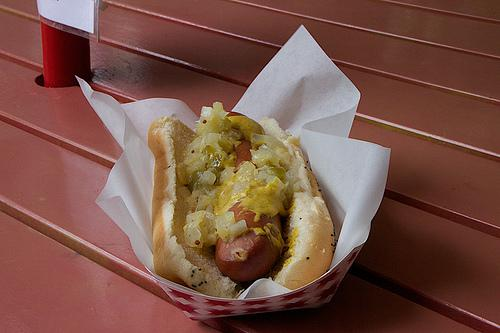Question: how many hotdogs on the table?
Choices:
A. Two.
B. Three.
C. One.
D. None.
Answer with the letter. Answer: C Question: who will eat the hot dog?
Choices:
A. A person.
B. A child.
C. A  man.
D. A dog.
Answer with the letter. Answer: A Question: why the hot dog on a paper box?
Choices:
A. To serve.
B. To hold easier.
C. So it won't be messy.
D. So it won't drip.
Answer with the letter. Answer: C Question: what is in the buns?
Choices:
A. Meat.
B. Ketchup.
C. Hot Dog.
D. Sausage link.
Answer with the letter. Answer: C 